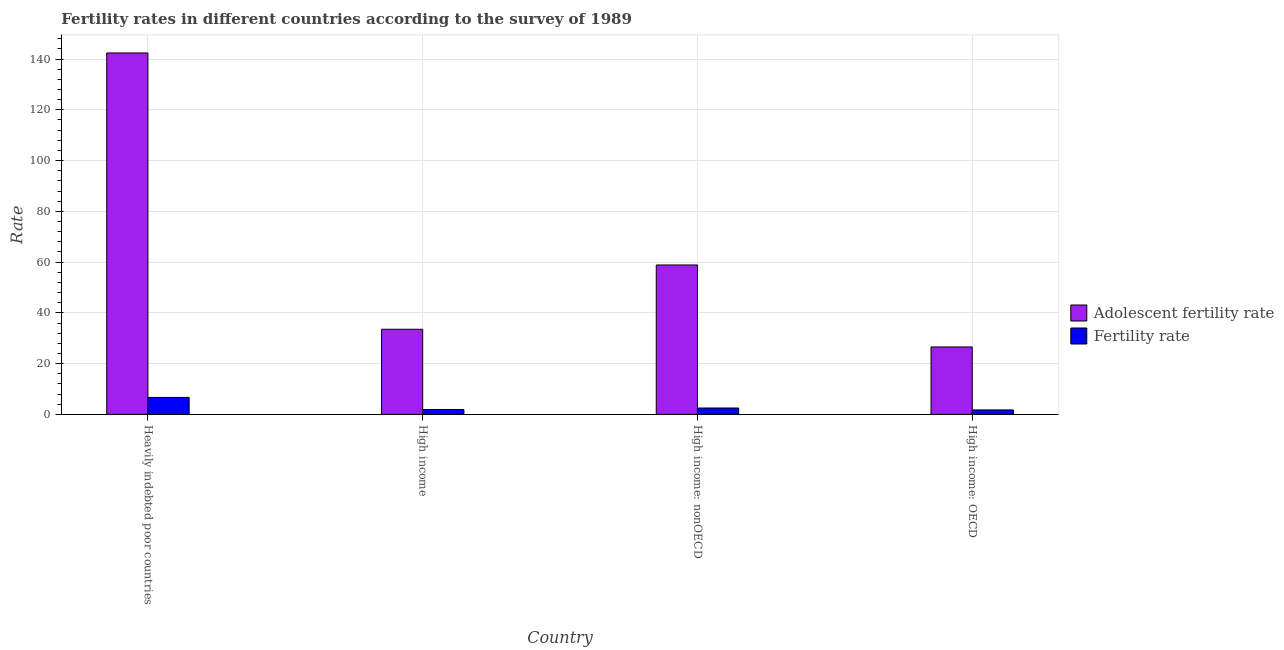How many bars are there on the 4th tick from the left?
Offer a terse response. 2. What is the label of the 1st group of bars from the left?
Offer a very short reply. Heavily indebted poor countries. What is the adolescent fertility rate in High income: OECD?
Keep it short and to the point. 26.57. Across all countries, what is the maximum fertility rate?
Offer a very short reply. 6.68. Across all countries, what is the minimum fertility rate?
Provide a succinct answer. 1.75. In which country was the fertility rate maximum?
Ensure brevity in your answer.  Heavily indebted poor countries. In which country was the adolescent fertility rate minimum?
Your response must be concise. High income: OECD. What is the total adolescent fertility rate in the graph?
Give a very brief answer. 261.37. What is the difference between the adolescent fertility rate in Heavily indebted poor countries and that in High income: OECD?
Offer a terse response. 115.84. What is the difference between the adolescent fertility rate in High income: OECD and the fertility rate in High income?
Give a very brief answer. 24.66. What is the average adolescent fertility rate per country?
Your answer should be very brief. 65.34. What is the difference between the fertility rate and adolescent fertility rate in High income: nonOECD?
Your answer should be compact. -56.35. What is the ratio of the fertility rate in Heavily indebted poor countries to that in High income?
Your answer should be compact. 3.5. Is the adolescent fertility rate in Heavily indebted poor countries less than that in High income?
Give a very brief answer. No. Is the difference between the fertility rate in Heavily indebted poor countries and High income: OECD greater than the difference between the adolescent fertility rate in Heavily indebted poor countries and High income: OECD?
Your answer should be very brief. No. What is the difference between the highest and the second highest fertility rate?
Provide a succinct answer. 4.18. What is the difference between the highest and the lowest fertility rate?
Give a very brief answer. 4.93. What does the 1st bar from the left in High income represents?
Ensure brevity in your answer.  Adolescent fertility rate. What does the 2nd bar from the right in High income represents?
Offer a very short reply. Adolescent fertility rate. How many bars are there?
Ensure brevity in your answer.  8. How many countries are there in the graph?
Your answer should be very brief. 4. Does the graph contain any zero values?
Keep it short and to the point. No. How many legend labels are there?
Provide a succinct answer. 2. How are the legend labels stacked?
Your response must be concise. Vertical. What is the title of the graph?
Offer a terse response. Fertility rates in different countries according to the survey of 1989. What is the label or title of the X-axis?
Keep it short and to the point. Country. What is the label or title of the Y-axis?
Offer a terse response. Rate. What is the Rate in Adolescent fertility rate in Heavily indebted poor countries?
Give a very brief answer. 142.41. What is the Rate in Fertility rate in Heavily indebted poor countries?
Ensure brevity in your answer.  6.68. What is the Rate of Adolescent fertility rate in High income?
Provide a succinct answer. 33.54. What is the Rate of Fertility rate in High income?
Provide a short and direct response. 1.91. What is the Rate of Adolescent fertility rate in High income: nonOECD?
Provide a short and direct response. 58.86. What is the Rate in Fertility rate in High income: nonOECD?
Your response must be concise. 2.51. What is the Rate of Adolescent fertility rate in High income: OECD?
Provide a succinct answer. 26.57. What is the Rate in Fertility rate in High income: OECD?
Offer a very short reply. 1.75. Across all countries, what is the maximum Rate of Adolescent fertility rate?
Offer a terse response. 142.41. Across all countries, what is the maximum Rate of Fertility rate?
Your answer should be very brief. 6.68. Across all countries, what is the minimum Rate of Adolescent fertility rate?
Offer a very short reply. 26.57. Across all countries, what is the minimum Rate of Fertility rate?
Ensure brevity in your answer.  1.75. What is the total Rate of Adolescent fertility rate in the graph?
Offer a very short reply. 261.37. What is the total Rate of Fertility rate in the graph?
Ensure brevity in your answer.  12.86. What is the difference between the Rate in Adolescent fertility rate in Heavily indebted poor countries and that in High income?
Your answer should be compact. 108.87. What is the difference between the Rate in Fertility rate in Heavily indebted poor countries and that in High income?
Make the answer very short. 4.78. What is the difference between the Rate of Adolescent fertility rate in Heavily indebted poor countries and that in High income: nonOECD?
Your answer should be compact. 83.54. What is the difference between the Rate of Fertility rate in Heavily indebted poor countries and that in High income: nonOECD?
Give a very brief answer. 4.18. What is the difference between the Rate in Adolescent fertility rate in Heavily indebted poor countries and that in High income: OECD?
Your answer should be very brief. 115.84. What is the difference between the Rate of Fertility rate in Heavily indebted poor countries and that in High income: OECD?
Your answer should be compact. 4.93. What is the difference between the Rate of Adolescent fertility rate in High income and that in High income: nonOECD?
Give a very brief answer. -25.33. What is the difference between the Rate of Fertility rate in High income and that in High income: nonOECD?
Your answer should be compact. -0.6. What is the difference between the Rate of Adolescent fertility rate in High income and that in High income: OECD?
Keep it short and to the point. 6.97. What is the difference between the Rate in Fertility rate in High income and that in High income: OECD?
Offer a terse response. 0.16. What is the difference between the Rate in Adolescent fertility rate in High income: nonOECD and that in High income: OECD?
Your answer should be compact. 32.29. What is the difference between the Rate of Fertility rate in High income: nonOECD and that in High income: OECD?
Provide a succinct answer. 0.76. What is the difference between the Rate of Adolescent fertility rate in Heavily indebted poor countries and the Rate of Fertility rate in High income?
Ensure brevity in your answer.  140.5. What is the difference between the Rate in Adolescent fertility rate in Heavily indebted poor countries and the Rate in Fertility rate in High income: nonOECD?
Offer a terse response. 139.9. What is the difference between the Rate of Adolescent fertility rate in Heavily indebted poor countries and the Rate of Fertility rate in High income: OECD?
Your answer should be very brief. 140.65. What is the difference between the Rate in Adolescent fertility rate in High income and the Rate in Fertility rate in High income: nonOECD?
Provide a short and direct response. 31.03. What is the difference between the Rate in Adolescent fertility rate in High income and the Rate in Fertility rate in High income: OECD?
Offer a very short reply. 31.78. What is the difference between the Rate in Adolescent fertility rate in High income: nonOECD and the Rate in Fertility rate in High income: OECD?
Keep it short and to the point. 57.11. What is the average Rate in Adolescent fertility rate per country?
Provide a succinct answer. 65.34. What is the average Rate of Fertility rate per country?
Keep it short and to the point. 3.21. What is the difference between the Rate in Adolescent fertility rate and Rate in Fertility rate in Heavily indebted poor countries?
Provide a succinct answer. 135.72. What is the difference between the Rate of Adolescent fertility rate and Rate of Fertility rate in High income?
Offer a terse response. 31.63. What is the difference between the Rate of Adolescent fertility rate and Rate of Fertility rate in High income: nonOECD?
Provide a succinct answer. 56.35. What is the difference between the Rate of Adolescent fertility rate and Rate of Fertility rate in High income: OECD?
Provide a short and direct response. 24.81. What is the ratio of the Rate in Adolescent fertility rate in Heavily indebted poor countries to that in High income?
Provide a short and direct response. 4.25. What is the ratio of the Rate of Fertility rate in Heavily indebted poor countries to that in High income?
Offer a very short reply. 3.5. What is the ratio of the Rate in Adolescent fertility rate in Heavily indebted poor countries to that in High income: nonOECD?
Make the answer very short. 2.42. What is the ratio of the Rate in Fertility rate in Heavily indebted poor countries to that in High income: nonOECD?
Give a very brief answer. 2.66. What is the ratio of the Rate in Adolescent fertility rate in Heavily indebted poor countries to that in High income: OECD?
Your answer should be very brief. 5.36. What is the ratio of the Rate in Fertility rate in Heavily indebted poor countries to that in High income: OECD?
Give a very brief answer. 3.81. What is the ratio of the Rate of Adolescent fertility rate in High income to that in High income: nonOECD?
Offer a very short reply. 0.57. What is the ratio of the Rate of Fertility rate in High income to that in High income: nonOECD?
Ensure brevity in your answer.  0.76. What is the ratio of the Rate of Adolescent fertility rate in High income to that in High income: OECD?
Keep it short and to the point. 1.26. What is the ratio of the Rate in Fertility rate in High income to that in High income: OECD?
Your answer should be very brief. 1.09. What is the ratio of the Rate of Adolescent fertility rate in High income: nonOECD to that in High income: OECD?
Offer a terse response. 2.22. What is the ratio of the Rate in Fertility rate in High income: nonOECD to that in High income: OECD?
Provide a succinct answer. 1.43. What is the difference between the highest and the second highest Rate in Adolescent fertility rate?
Provide a short and direct response. 83.54. What is the difference between the highest and the second highest Rate of Fertility rate?
Your answer should be compact. 4.18. What is the difference between the highest and the lowest Rate of Adolescent fertility rate?
Provide a short and direct response. 115.84. What is the difference between the highest and the lowest Rate in Fertility rate?
Your answer should be compact. 4.93. 